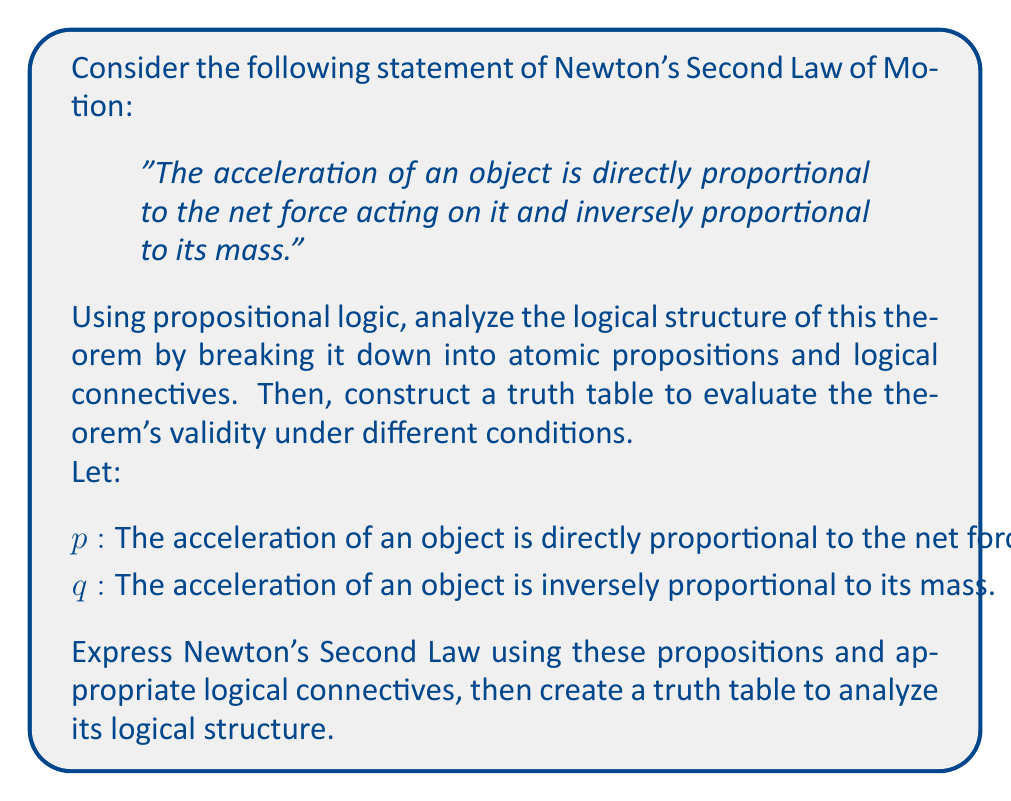Teach me how to tackle this problem. To analyze the logical structure of Newton's Second Law using propositional logic, we need to follow these steps:

1. Express the law using logical connectives:
   Newton's Second Law can be expressed as the conjunction of two propositions:
   $p \land q$

   This means that both statements must be true for the law to hold.

2. Construct a truth table:
   We need to evaluate the truth value of $p \land q$ for all possible combinations of $p$ and $q$.

   $$
   \begin{array}{|c|c|c|}
   \hline
   p & q & p \land q \\
   \hline
   T & T & T \\
   T & F & F \\
   F & T & F \\
   F & F & F \\
   \hline
   \end{array}
   $$

3. Interpret the truth table:
   - The theorem is only true when both $p$ and $q$ are true.
   - If either $p$ or $q$ is false, the theorem is false.

4. Physical interpretation:
   - When $p$ is true and $q$ is false: This would represent a situation where acceleration is proportional to force but not inversely proportional to mass, which violates the law.
   - When $p$ is false and $q$ is true: This represents a situation where acceleration is inversely proportional to mass but not proportional to force, which also violates the law.
   - When both $p$ and $q$ are false: This completely contradicts the law.

5. Validity of the theorem:
   The theorem is logically valid because there exists a combination of truth values (when both $p$ and $q$ are true) that makes the entire statement true. This aligns with our understanding of Newton's Second Law in physics.

6. Connection to experimental physics:
   As a physicist inspired by Christian Janot, you would recognize that this logical analysis provides a framework for experimental validation. Experiments can be designed to test the individual propositions $p$ and $q$, as well as their conjunction, to verify the law's applicability in various physical scenarios.
Answer: The logical structure of Newton's Second Law can be expressed as $p \land q$, where $p$ and $q$ represent the two key components of the law. The truth table analysis shows that the law is only true when both components are true, which aligns with the physical reality. This logical structure provides a framework for experimental validation in physics. 